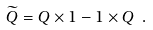Convert formula to latex. <formula><loc_0><loc_0><loc_500><loc_500>\widetilde { Q } = Q \times { 1 } - { 1 } \times Q \ .</formula> 